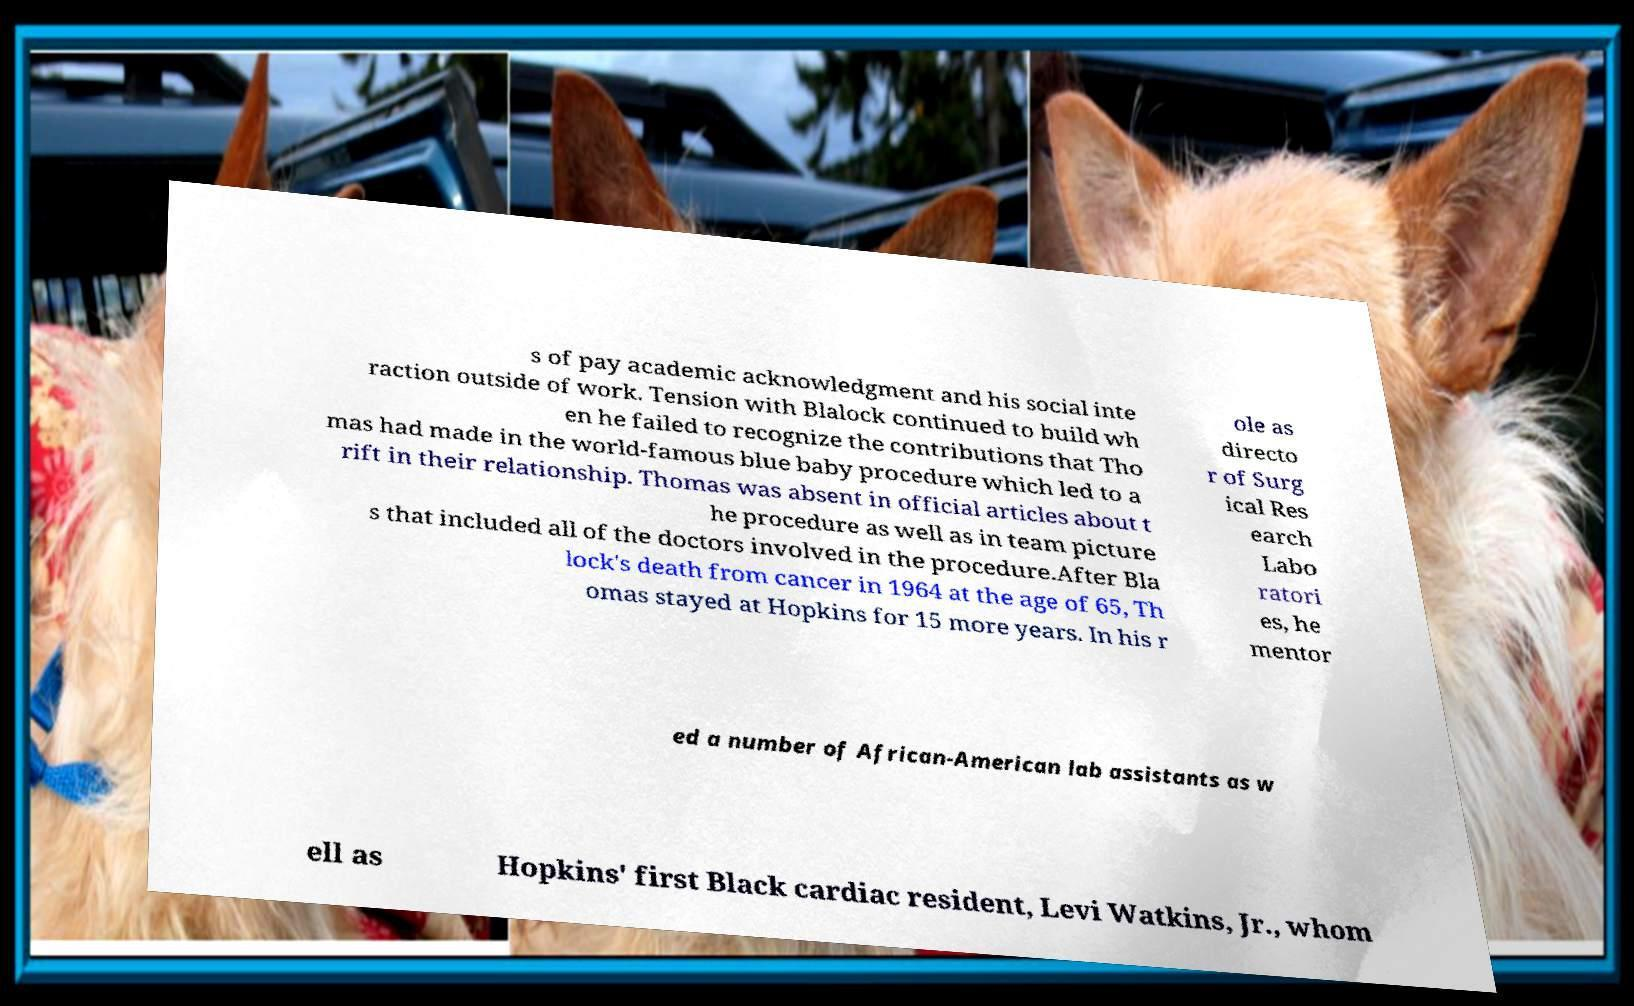Please read and relay the text visible in this image. What does it say? s of pay academic acknowledgment and his social inte raction outside of work. Tension with Blalock continued to build wh en he failed to recognize the contributions that Tho mas had made in the world-famous blue baby procedure which led to a rift in their relationship. Thomas was absent in official articles about t he procedure as well as in team picture s that included all of the doctors involved in the procedure.After Bla lock's death from cancer in 1964 at the age of 65, Th omas stayed at Hopkins for 15 more years. In his r ole as directo r of Surg ical Res earch Labo ratori es, he mentor ed a number of African-American lab assistants as w ell as Hopkins' first Black cardiac resident, Levi Watkins, Jr., whom 